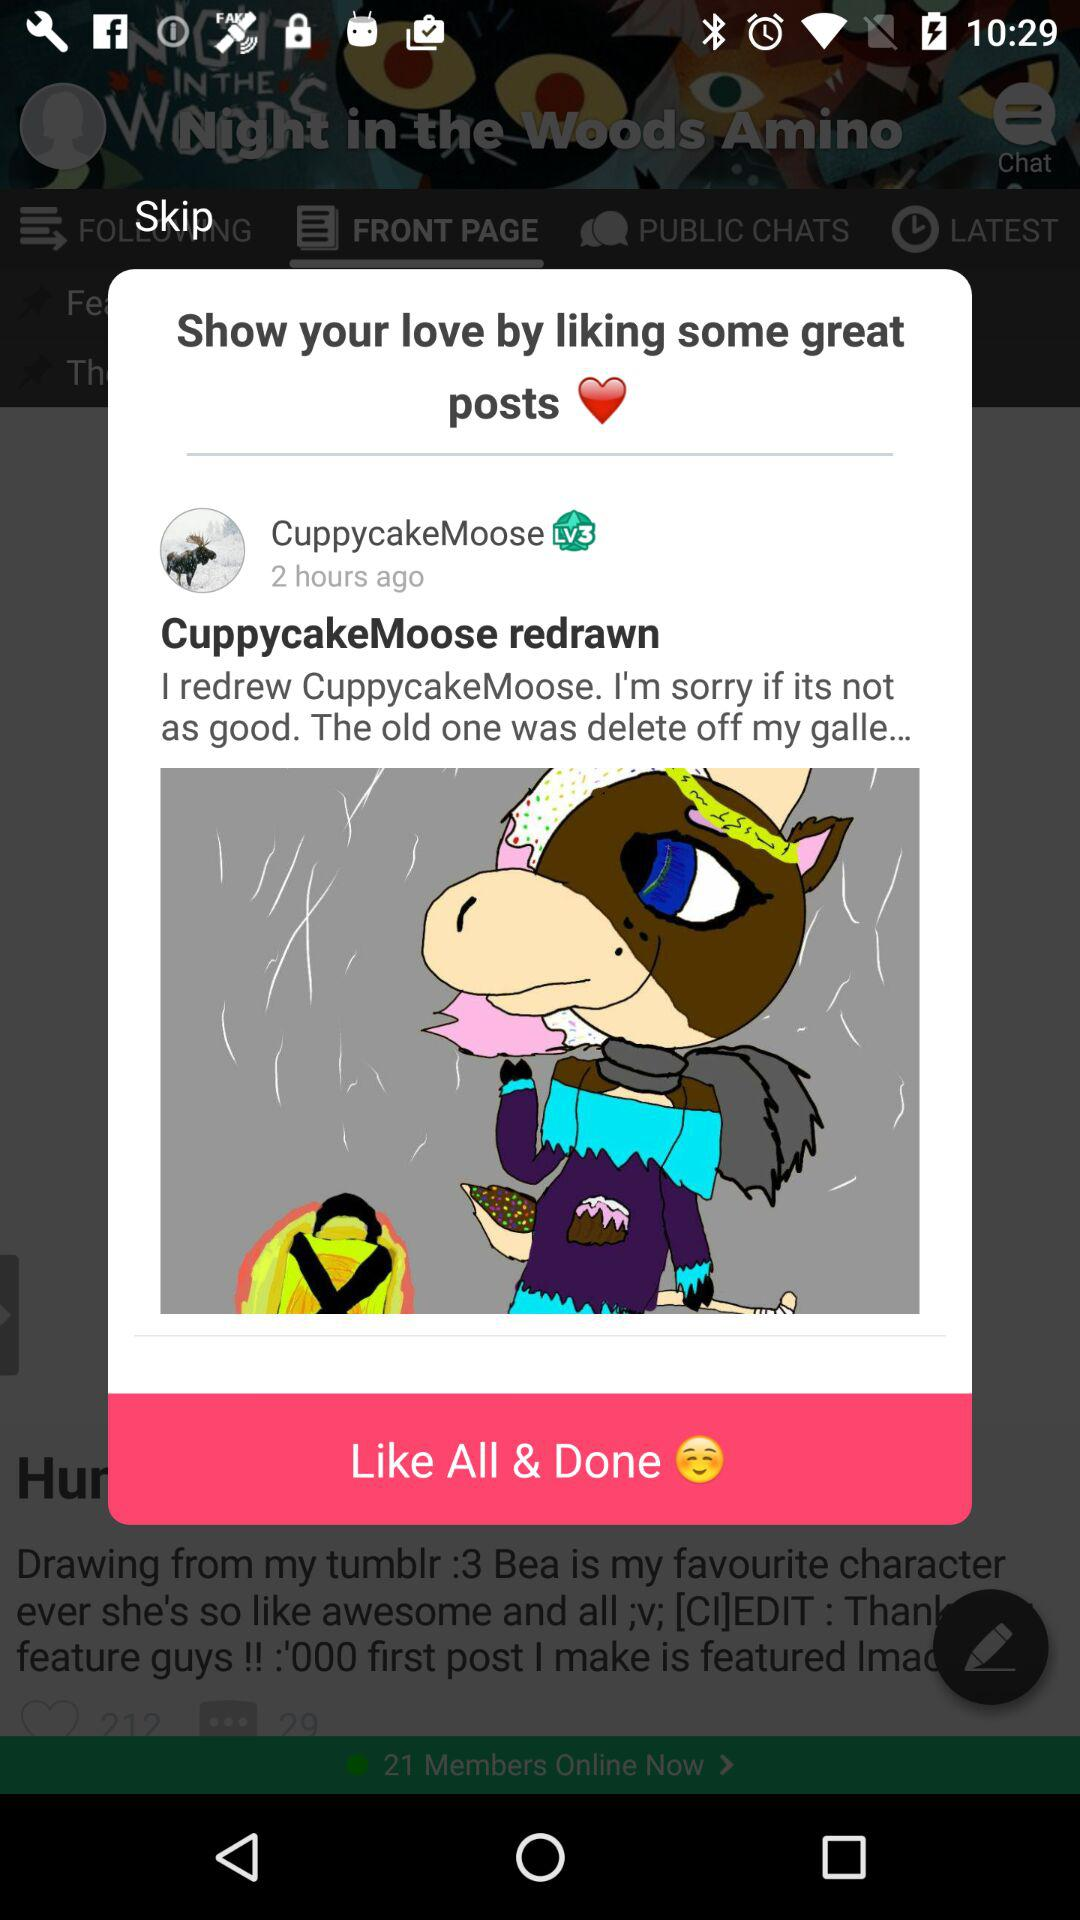How many hours ago was the post made?
Answer the question using a single word or phrase. 2 